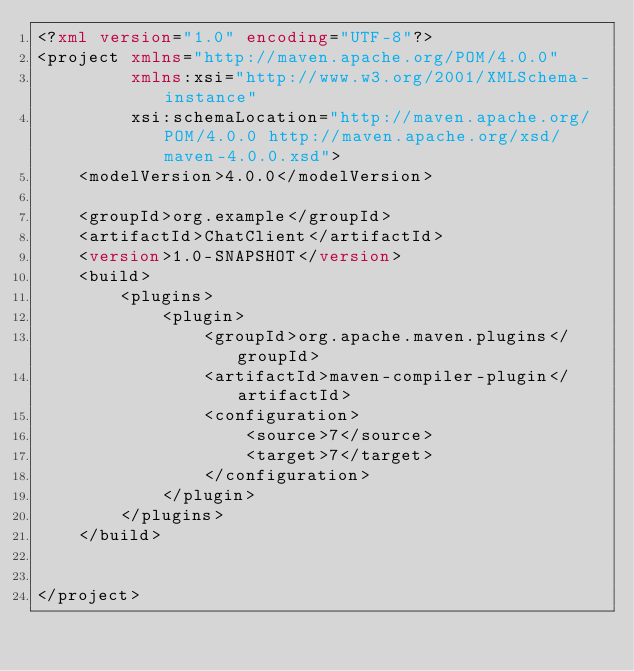Convert code to text. <code><loc_0><loc_0><loc_500><loc_500><_XML_><?xml version="1.0" encoding="UTF-8"?>
<project xmlns="http://maven.apache.org/POM/4.0.0"
         xmlns:xsi="http://www.w3.org/2001/XMLSchema-instance"
         xsi:schemaLocation="http://maven.apache.org/POM/4.0.0 http://maven.apache.org/xsd/maven-4.0.0.xsd">
    <modelVersion>4.0.0</modelVersion>

    <groupId>org.example</groupId>
    <artifactId>ChatClient</artifactId>
    <version>1.0-SNAPSHOT</version>
    <build>
        <plugins>
            <plugin>
                <groupId>org.apache.maven.plugins</groupId>
                <artifactId>maven-compiler-plugin</artifactId>
                <configuration>
                    <source>7</source>
                    <target>7</target>
                </configuration>
            </plugin>
        </plugins>
    </build>


</project></code> 